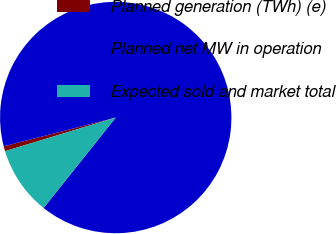Convert chart to OTSL. <chart><loc_0><loc_0><loc_500><loc_500><pie_chart><fcel>Planned generation (TWh) (e)<fcel>Planned net MW in operation<fcel>Expected sold and market total<nl><fcel>0.69%<fcel>89.72%<fcel>9.59%<nl></chart> 